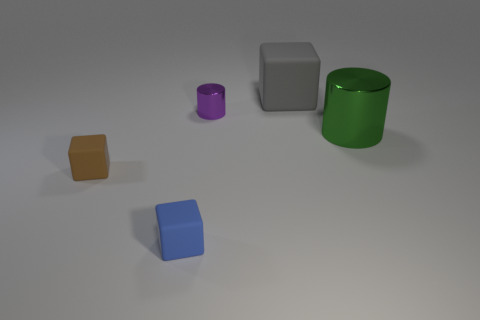Add 1 yellow rubber things. How many objects exist? 6 Subtract all cubes. How many objects are left? 2 Subtract all red metallic cylinders. Subtract all blue rubber things. How many objects are left? 4 Add 5 blue matte blocks. How many blue matte blocks are left? 6 Add 2 green metallic cylinders. How many green metallic cylinders exist? 3 Subtract 0 brown balls. How many objects are left? 5 